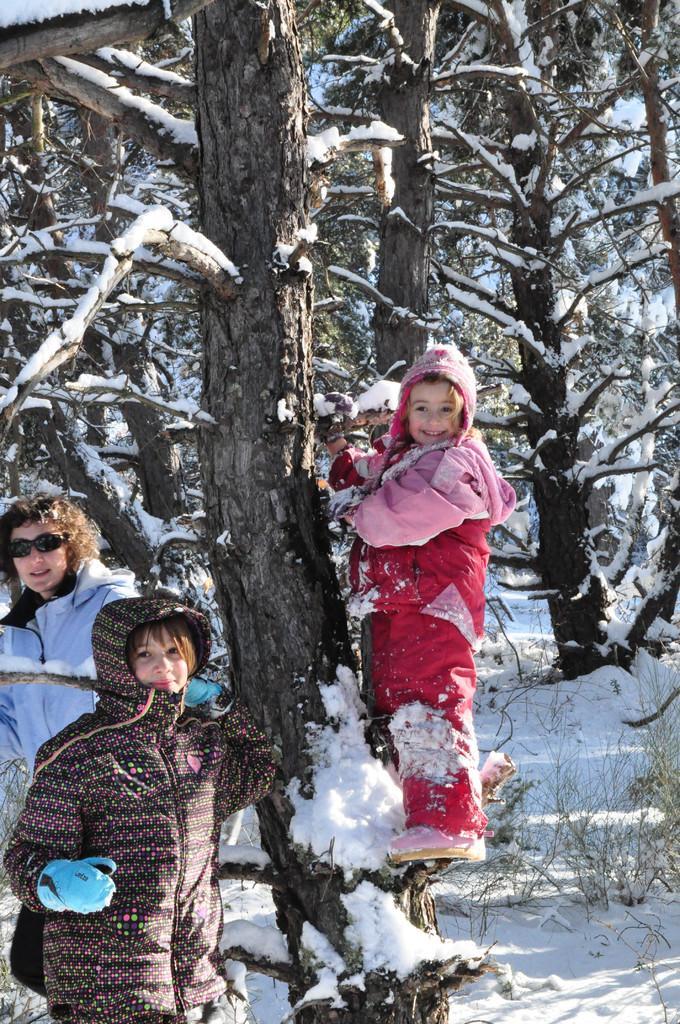Could you give a brief overview of what you see in this image? In this image I can see three persons standing, the person in front wearing pink color jacket. Background I can see trees covered with snow and the snow is in white color. 